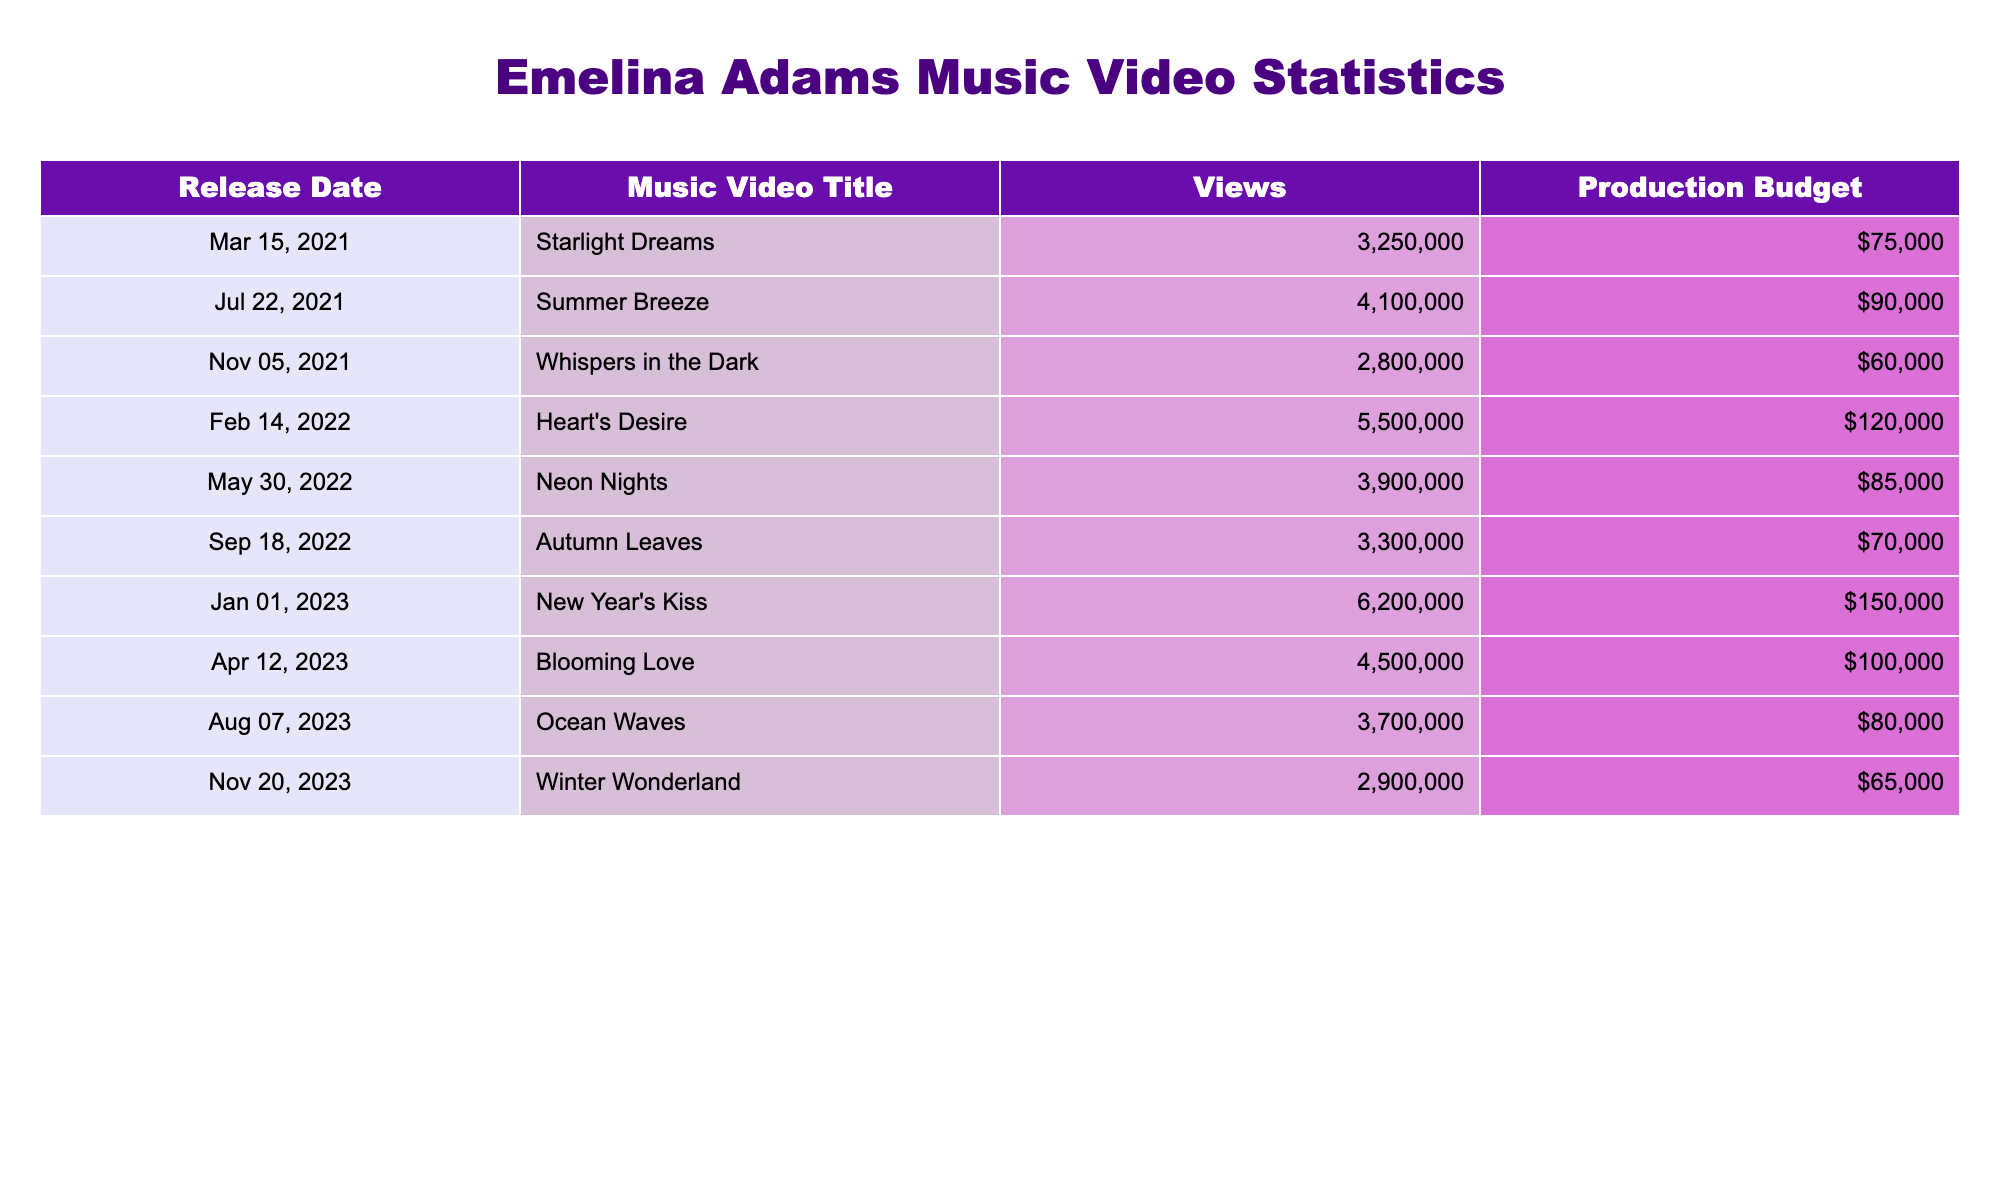What is the highest number of views for an Emelina Adams music video? The table shows the views for each music video, and the highest value is 6,200,000 for "New Year's Kiss."
Answer: 6,200,000 What music video was released on February 14, 2022? By looking at the "Release Date" column, "Heart's Desire" is listed for that date.
Answer: Heart's Desire What is the production budget for "Whispers in the Dark"? The budget for "Whispers in the Dark" is listed in the table as $60,000.
Answer: $60,000 How many total views do all the music videos have combined? Adding up all the views: 3,250,000 + 4,100,000 + 2,800,000 + 5,500,000 + 3,900,000 + 3,300,000 + 6,200,000 + 4,500,000 + 3,700,000 + 2,900,000 equals 40,150,000.
Answer: 40,150,000 What is the average production budget of Emelina Adams' music videos? There are 10 videos and their budgets are: 75,000, 90,000, 60,000, 120,000, 85,000, 70,000, 150,000, 100,000, 80,000, and 65,000. Summing these gives 1,025,000 and dividing by 10 results in an average of 102,500.
Answer: 102,500 Is the production budget for "Summer Breeze" higher than that for "Ocean Waves"? "Summer Breeze" has a budget of $90,000 while "Ocean Waves" has $80,000. Since $90,000 > $80,000, the statement is true.
Answer: Yes Which music video released on March 15, 2021, had views greater than 3 million? "Starlight Dreams," released on that date, has 3,250,000 views, which is greater than 3 million. Therefore, it meets the condition.
Answer: Starlight Dreams What is the difference in views between "New Year's Kiss" and "Autumn Leaves"? "New Year's Kiss" has 6,200,000 views and "Autumn Leaves" has 3,300,000 views. The difference is 6,200,000 - 3,300,000 = 2,900,000.
Answer: 2,900,000 Which music video had the lowest production budget? Upon examining the budgets, "Whispers in the Dark" has the lowest budget of $60,000.
Answer: Whispers in the Dark What is the production budget of the music video with the highest views? The music video with the highest views is "New Year's Kiss," which has a production budget of $150,000.
Answer: $150,000 